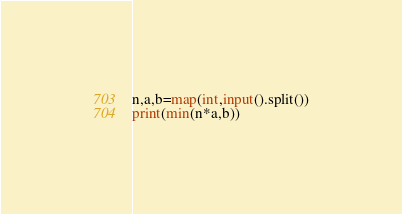<code> <loc_0><loc_0><loc_500><loc_500><_Python_>n,a,b=map(int,input().split())
print(min(n*a,b))
</code> 